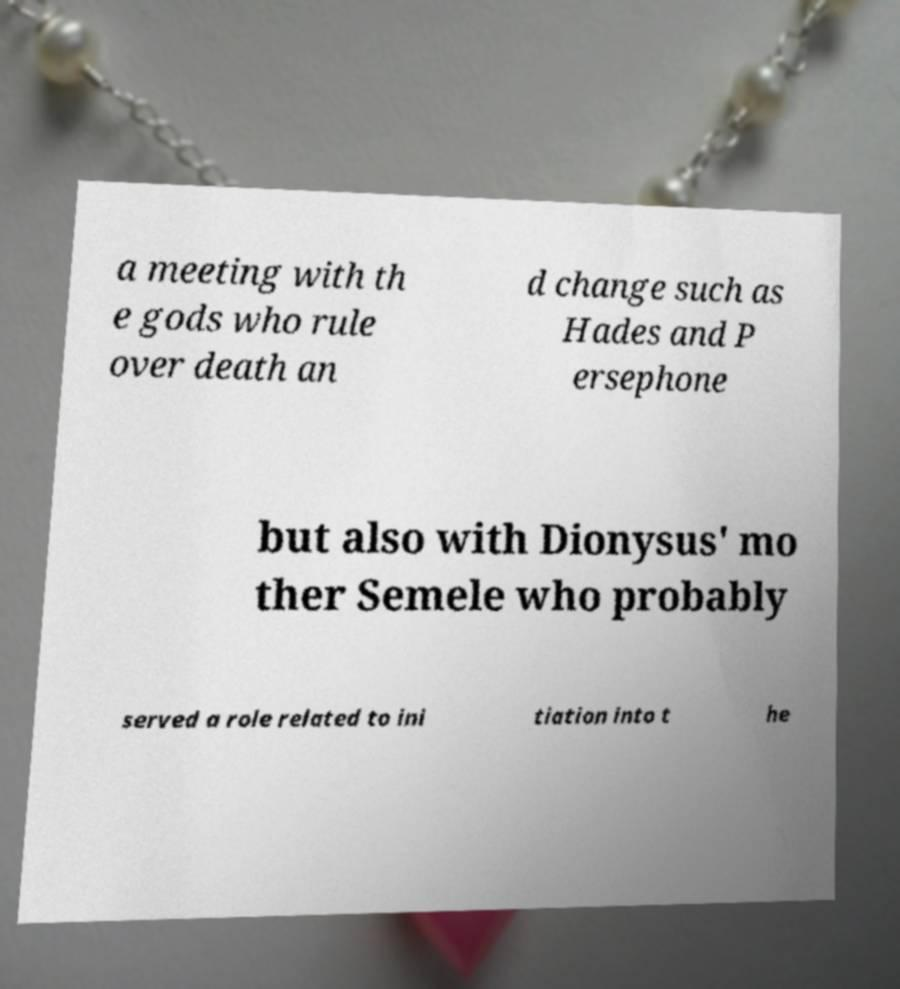Can you accurately transcribe the text from the provided image for me? a meeting with th e gods who rule over death an d change such as Hades and P ersephone but also with Dionysus' mo ther Semele who probably served a role related to ini tiation into t he 